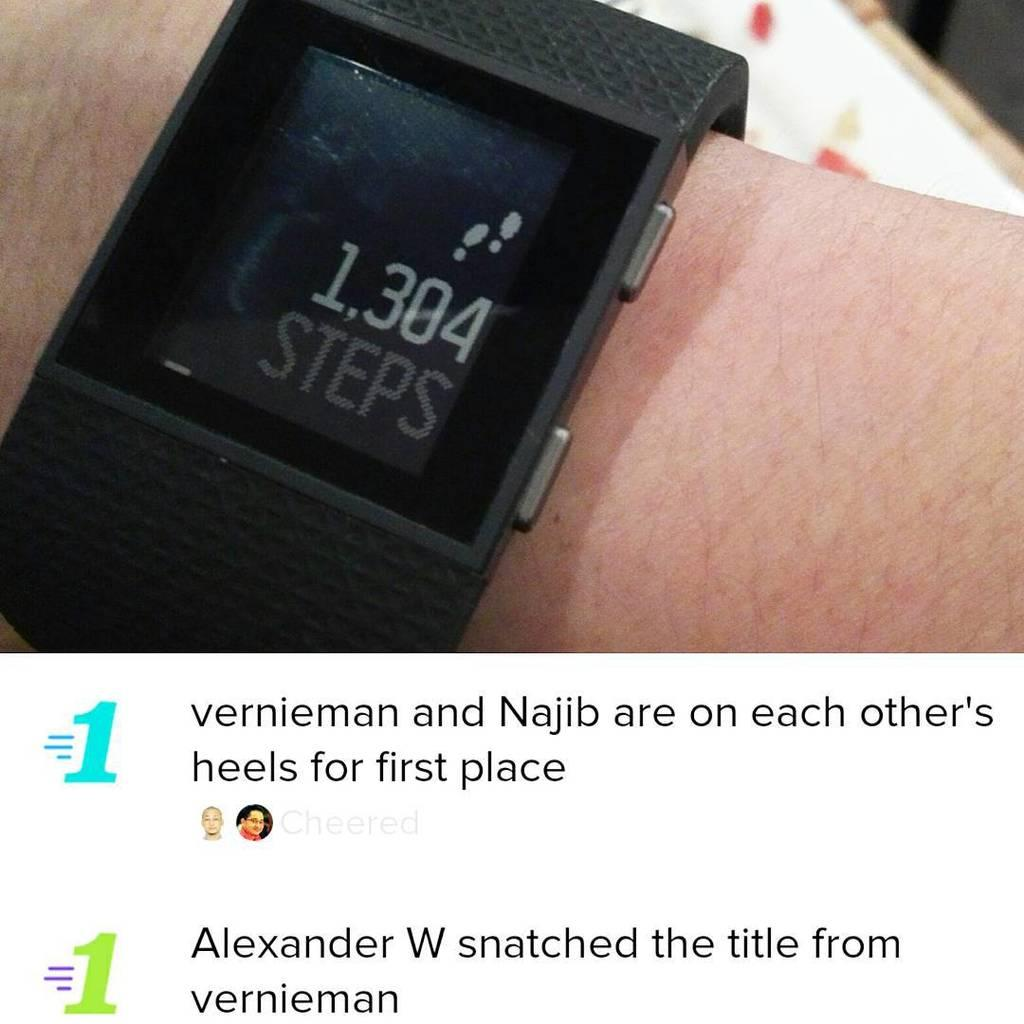<image>
Describe the image concisely. The fitness watch reads that person has taken 1304 steps. 